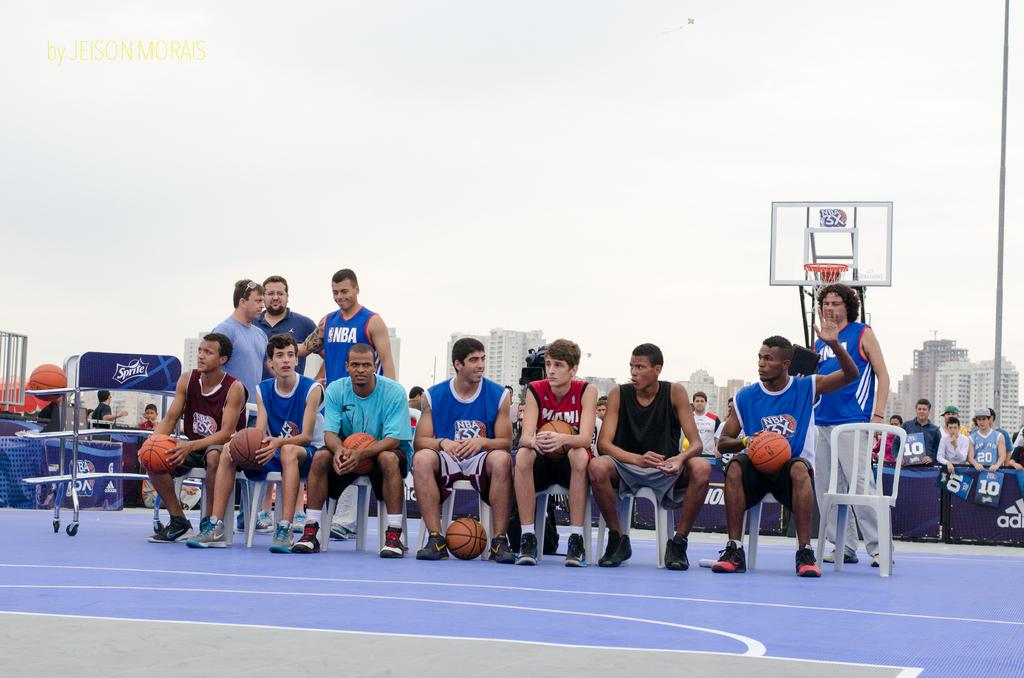<image>
Provide a brief description of the given image. A group of seven young men sit in chairs on a blue, outdoor basketball court with 4 men standing behind them in this photo by Jeison Morais. 